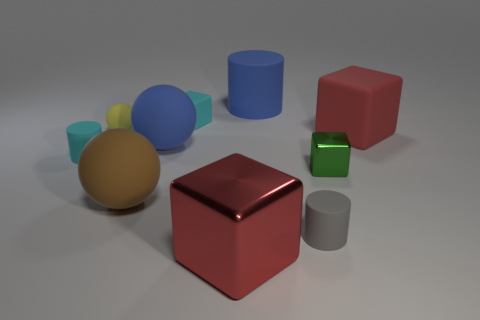Are there more tiny purple rubber cubes than objects?
Offer a terse response. No. Is there any other thing of the same color as the large matte cylinder?
Offer a very short reply. Yes. The red object that is the same material as the yellow sphere is what shape?
Provide a succinct answer. Cube. There is a big red block to the left of the big thing that is on the right side of the gray cylinder; what is it made of?
Provide a short and direct response. Metal. There is a large blue object left of the big red metallic cube; is its shape the same as the tiny shiny object?
Your answer should be very brief. No. Are there more big rubber objects that are right of the gray cylinder than large purple rubber cylinders?
Offer a terse response. Yes. Is there anything else that is the same material as the tiny yellow thing?
Provide a succinct answer. Yes. There is a rubber object that is the same color as the big shiny cube; what shape is it?
Provide a succinct answer. Cube. What number of blocks are large red rubber objects or gray rubber objects?
Your answer should be very brief. 1. What is the color of the tiny cube behind the small rubber cylinder left of the blue cylinder?
Provide a succinct answer. Cyan. 